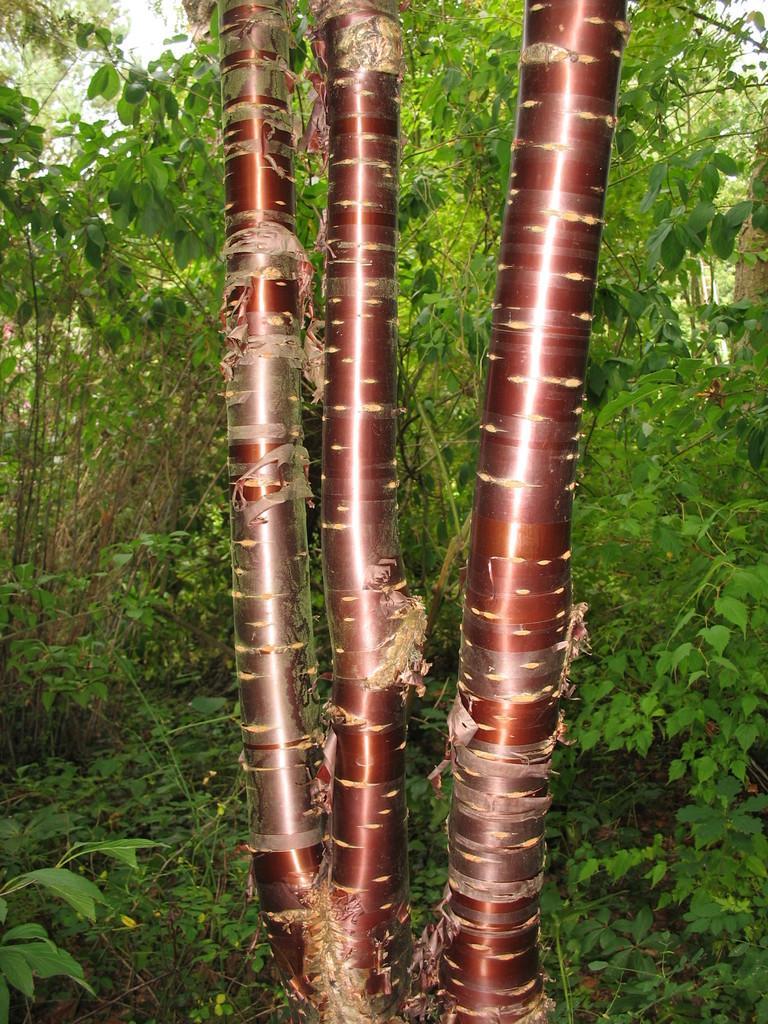In one or two sentences, can you explain what this image depicts? In this image in the front there is branch of a tree. In the background there are trees. On the ground there is grass. 